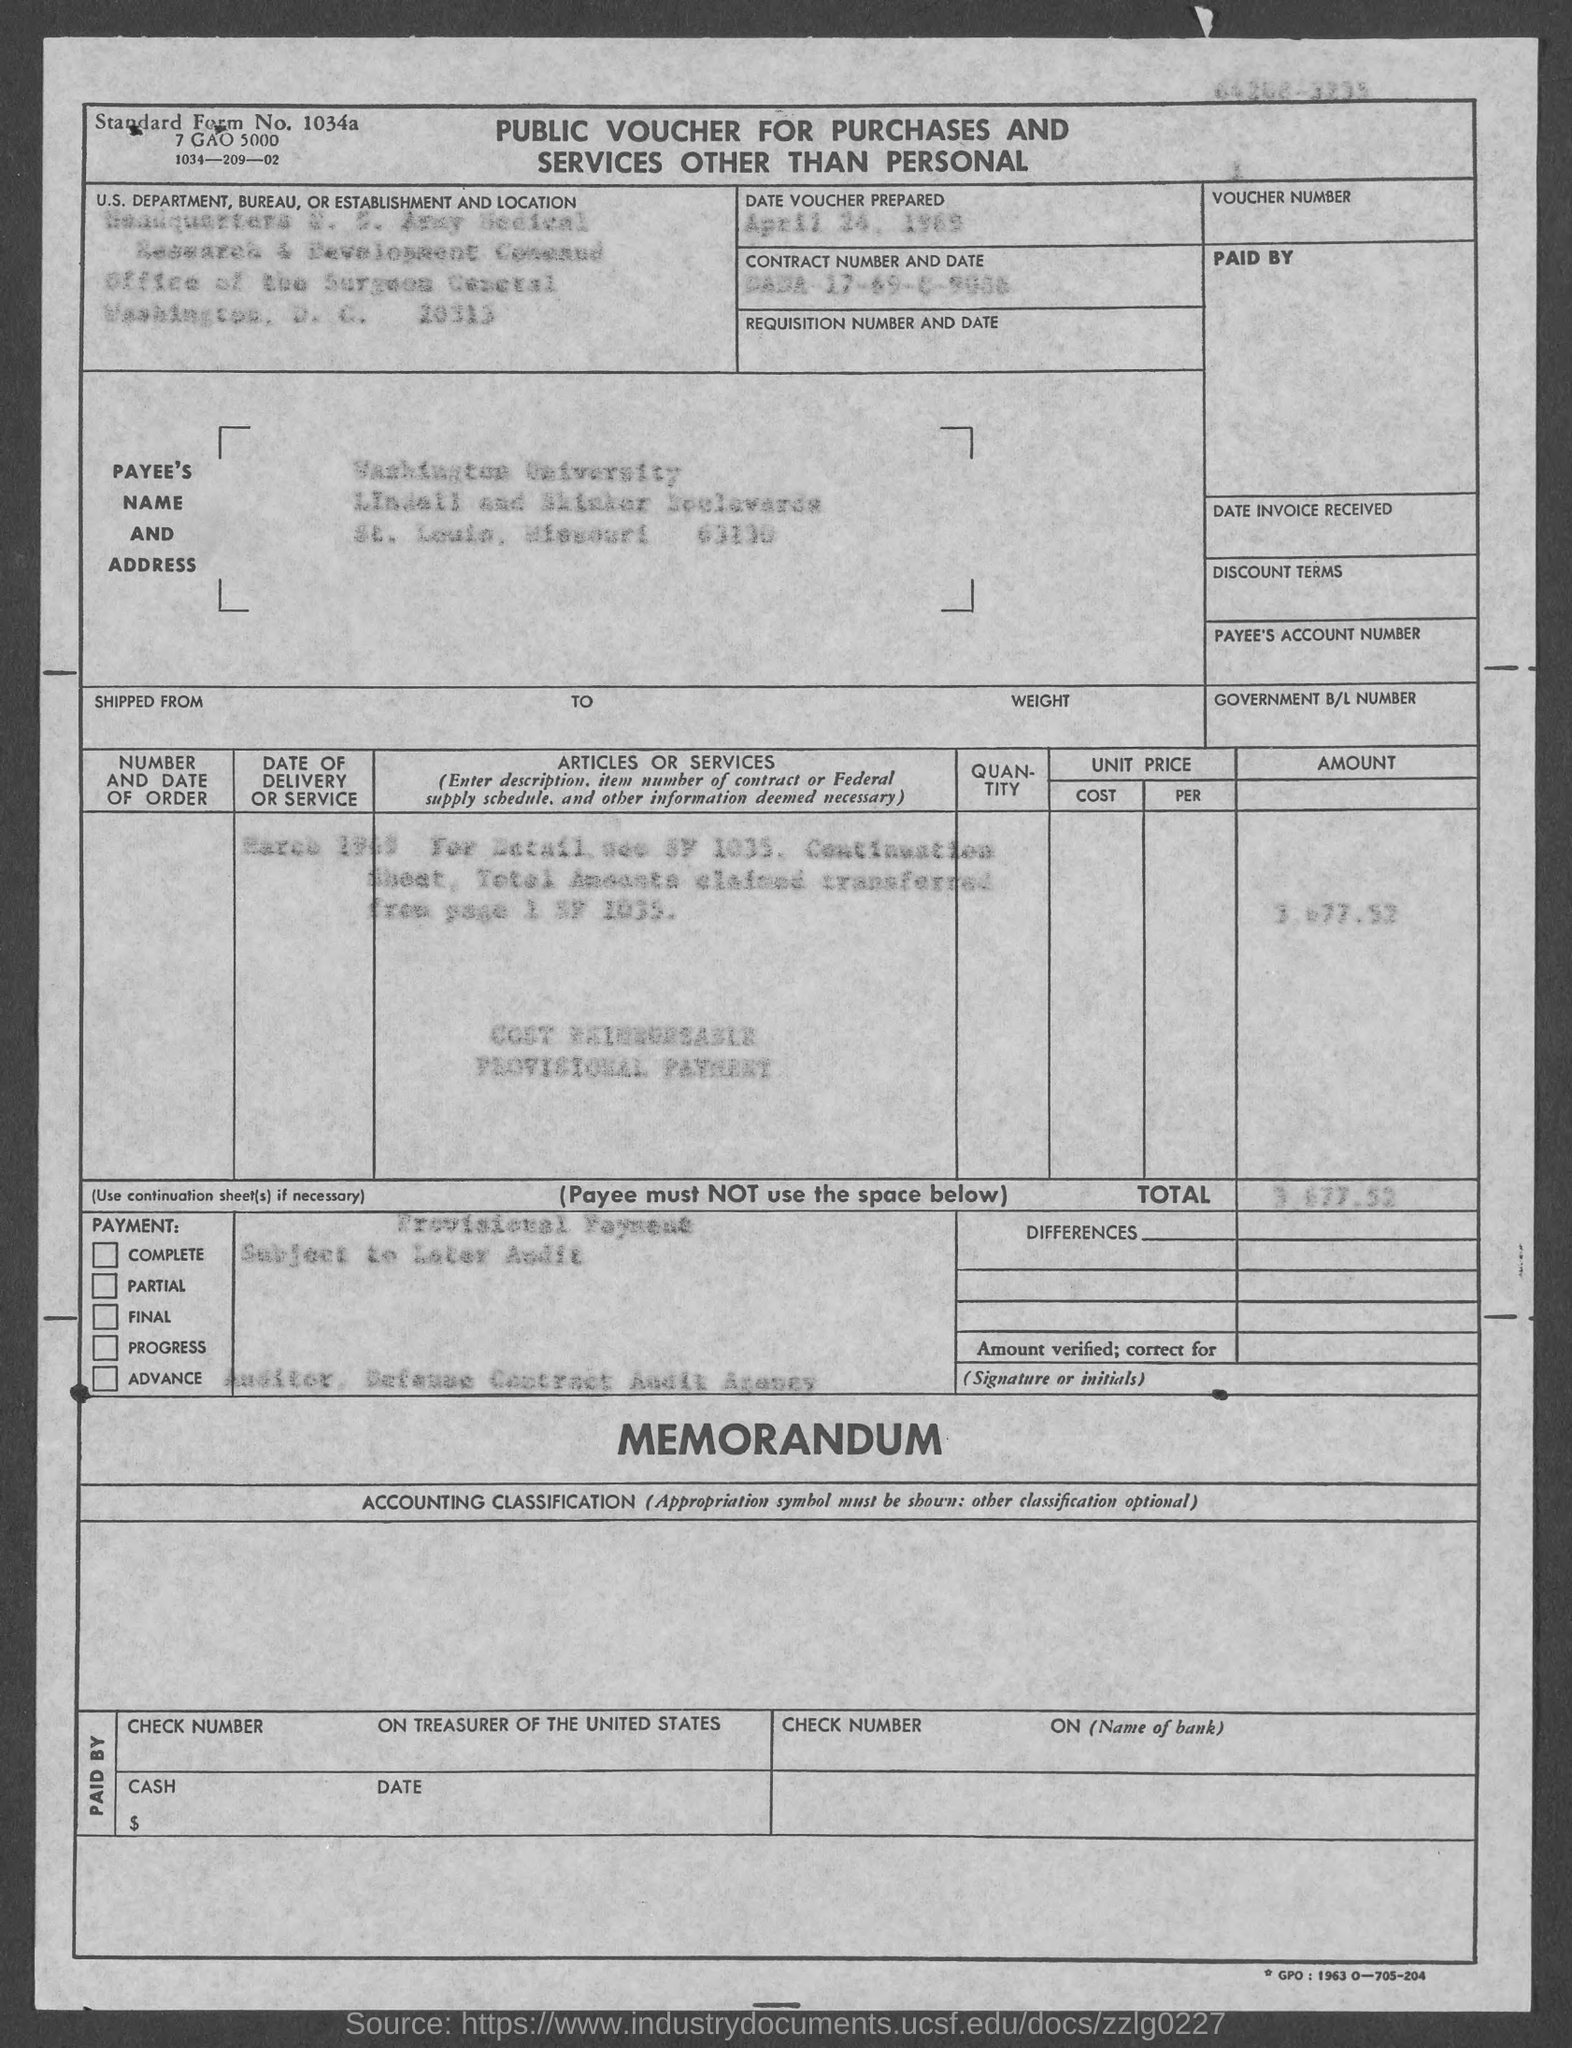When was the voucher prepared?
Make the answer very short. April 24, 1969. 